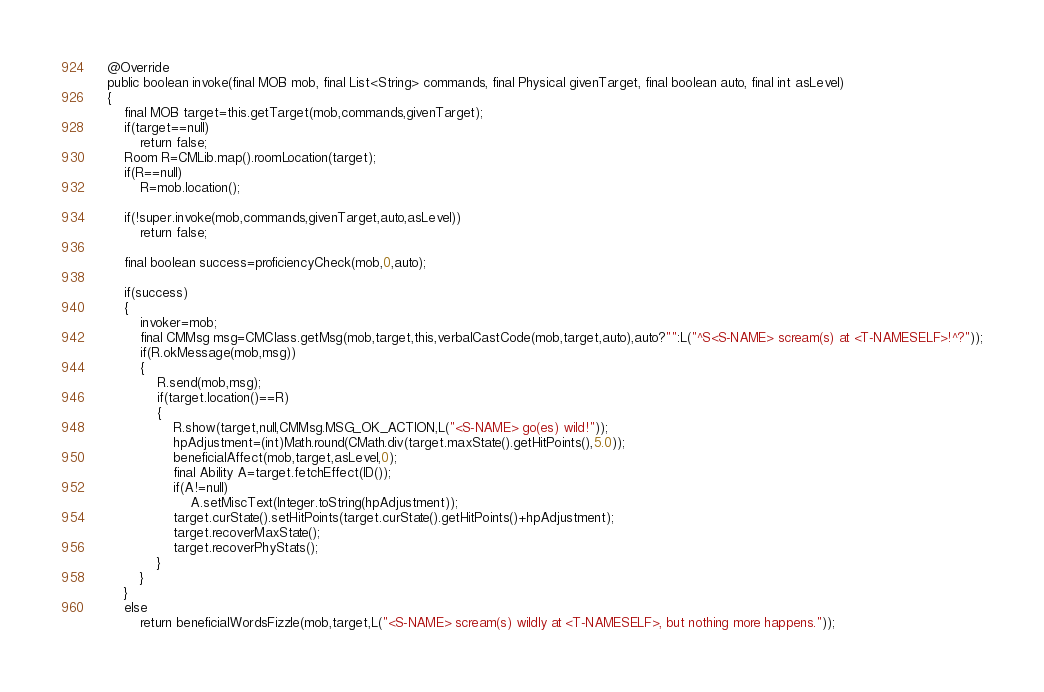<code> <loc_0><loc_0><loc_500><loc_500><_Java_>	@Override
	public boolean invoke(final MOB mob, final List<String> commands, final Physical givenTarget, final boolean auto, final int asLevel)
	{
		final MOB target=this.getTarget(mob,commands,givenTarget);
		if(target==null)
			return false;
		Room R=CMLib.map().roomLocation(target);
		if(R==null)
			R=mob.location();

		if(!super.invoke(mob,commands,givenTarget,auto,asLevel))
			return false;

		final boolean success=proficiencyCheck(mob,0,auto);

		if(success)
		{
			invoker=mob;
			final CMMsg msg=CMClass.getMsg(mob,target,this,verbalCastCode(mob,target,auto),auto?"":L("^S<S-NAME> scream(s) at <T-NAMESELF>!^?"));
			if(R.okMessage(mob,msg))
			{
				R.send(mob,msg);
				if(target.location()==R)
				{
					R.show(target,null,CMMsg.MSG_OK_ACTION,L("<S-NAME> go(es) wild!"));
					hpAdjustment=(int)Math.round(CMath.div(target.maxState().getHitPoints(),5.0));
					beneficialAffect(mob,target,asLevel,0);
					final Ability A=target.fetchEffect(ID());
					if(A!=null)
						A.setMiscText(Integer.toString(hpAdjustment));
					target.curState().setHitPoints(target.curState().getHitPoints()+hpAdjustment);
					target.recoverMaxState();
					target.recoverPhyStats();
				}
			}
		}
		else
			return beneficialWordsFizzle(mob,target,L("<S-NAME> scream(s) wildly at <T-NAMESELF>, but nothing more happens."));
</code> 